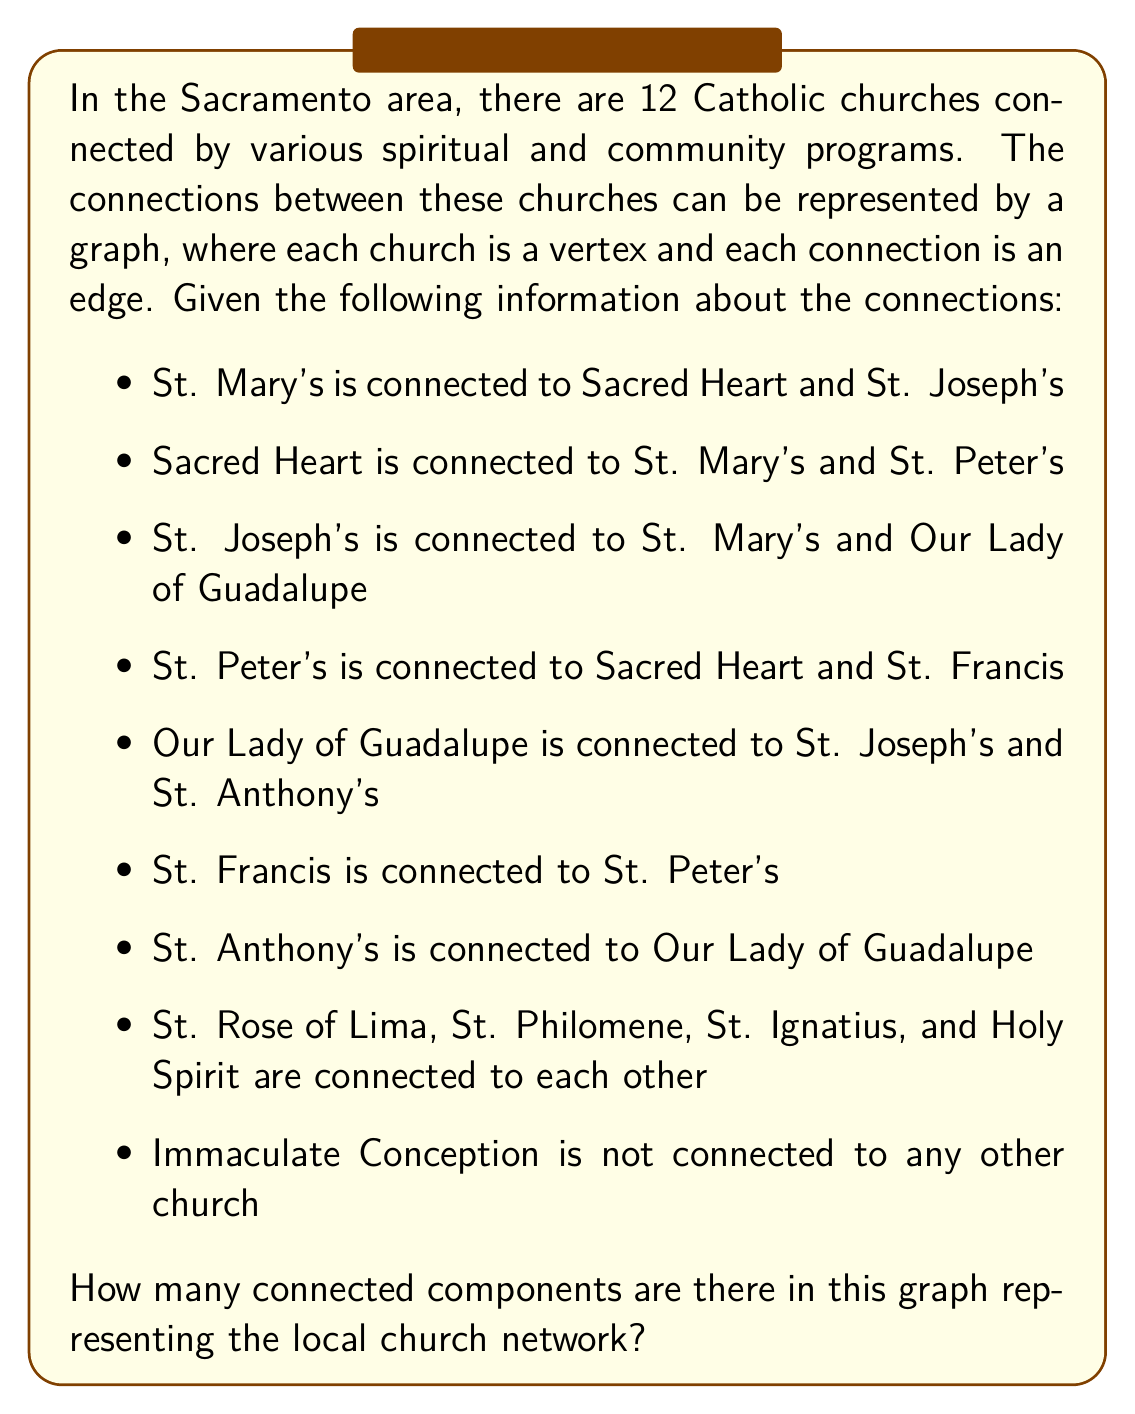Show me your answer to this math problem. To determine the number of connected components in this graph, we need to identify groups of churches that are connected to each other, either directly or indirectly. Let's break this down step-by-step:

1. First, let's identify the largest connected component:
   - St. Mary's, Sacred Heart, St. Joseph's, St. Peter's, Our Lady of Guadalupe, St. Francis, and St. Anthony's form one connected component. We can verify this by tracing the connections:
     St. Mary's → Sacred Heart → St. Peter's → St. Francis
     St. Mary's → St. Joseph's → Our Lady of Guadalupe → St. Anthony's

2. Next, we have another connected component:
   - St. Rose of Lima, St. Philomene, St. Ignatius, and Holy Spirit form a separate connected component, as they are all connected to each other but not to any church in the first group.

3. Finally, we have an isolated church:
   - Immaculate Conception is not connected to any other church, forming its own connected component.

To visualize this, we can represent the graph as follows:

[asy]
unitsize(1cm);

pair[] pos = {(0,0), (2,0), (4,0), (6,0), (8,0), (10,0), (12,0), (2,-3), (4,-3), (6,-3), (8,-3), (6,-6)};

draw(pos[0]--pos[1]--pos[2]--pos[0]);
draw(pos[1]--pos[3]--pos[4]);
draw(pos[2]--pos[4]--pos[5]);
draw(pos[4]--pos[6]);

draw(pos[7]--pos[8]--pos[9]--pos[10]--pos[7]);
draw(pos[8]--pos[10]);
draw(pos[7]--pos[9]);

for(int i=0; i<12; ++i) {
    dot(pos[i]);
}

label("St. Mary's", pos[0], SW);
label("Sacred Heart", pos[1], S);
label("St. Joseph's", pos[2], S);
label("St. Peter's", pos[3], S);
label("Our Lady of Guadalupe", pos[4], S);
label("St. Francis", pos[5], S);
label("St. Anthony's", pos[6], S);
label("St. Rose", pos[7], SW);
label("St. Philomene", pos[8], S);
label("St. Ignatius", pos[9], S);
label("Holy Spirit", pos[10], SE);
label("Immaculate Conception", pos[11], S);
[/asy]

In graph theory, a connected component is a subgraph in which any two vertices are connected to each other by paths, and which is connected to no additional vertices in the supergraph. 

From our analysis, we can clearly see that there are three distinct connected components in this graph:
1. The large component with 7 churches
2. The smaller component with 4 churches
3. The isolated church (Immaculate Conception)

Therefore, the total number of connected components in this graph is 3.
Answer: The graph representing the local church network has 3 connected components. 